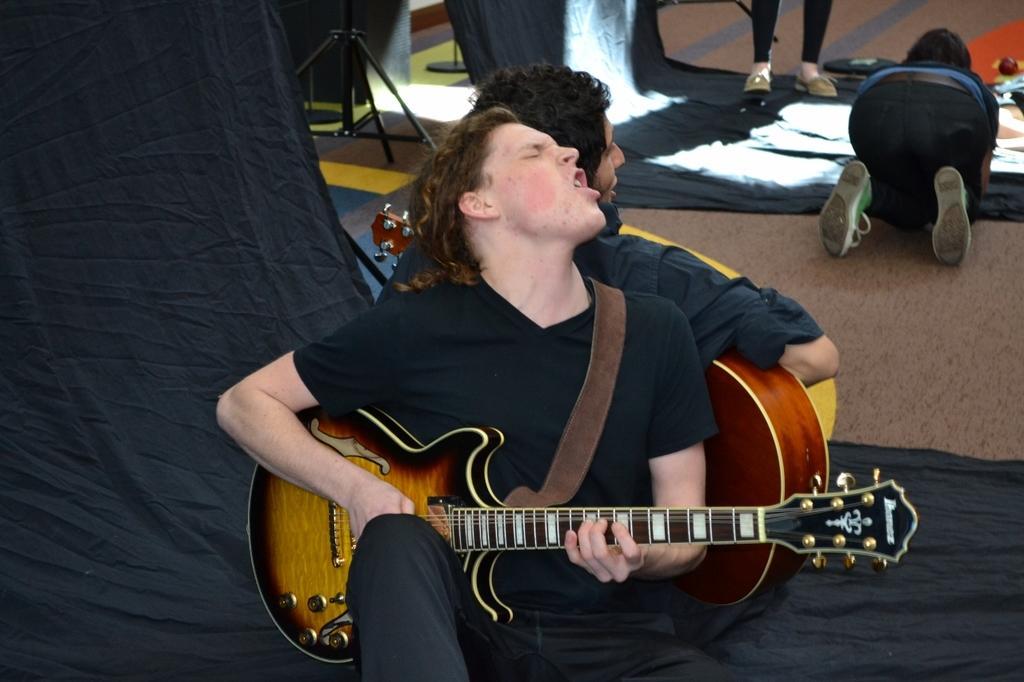In one or two sentences, can you explain what this image depicts? As we can see in the image there are four people. Among them two of them are sitting and holding guitar in their hands. 